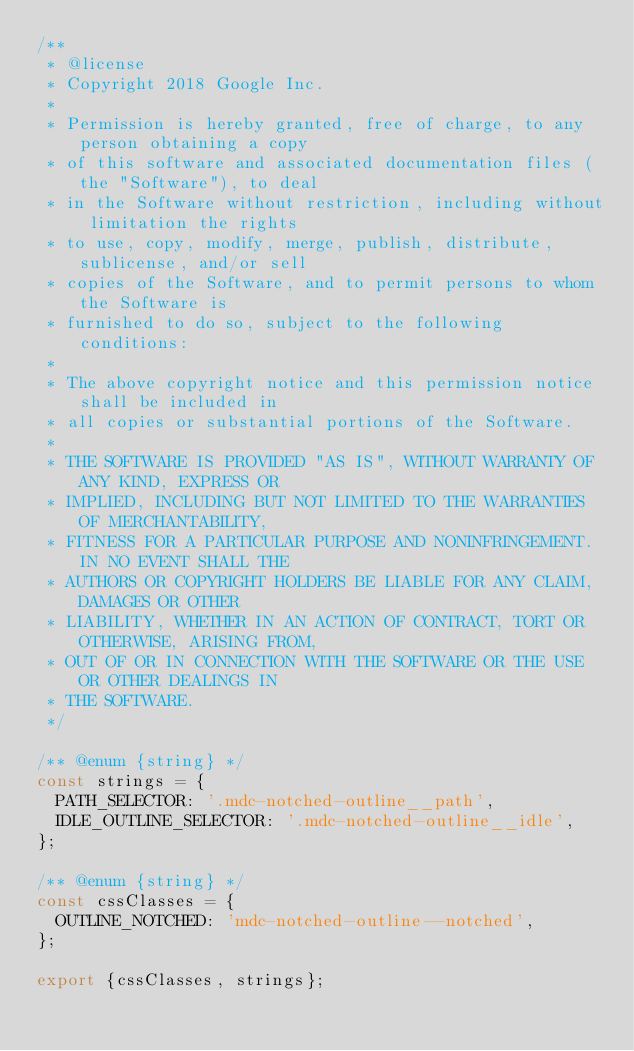<code> <loc_0><loc_0><loc_500><loc_500><_JavaScript_>/**
 * @license
 * Copyright 2018 Google Inc.
 *
 * Permission is hereby granted, free of charge, to any person obtaining a copy
 * of this software and associated documentation files (the "Software"), to deal
 * in the Software without restriction, including without limitation the rights
 * to use, copy, modify, merge, publish, distribute, sublicense, and/or sell
 * copies of the Software, and to permit persons to whom the Software is
 * furnished to do so, subject to the following conditions:
 *
 * The above copyright notice and this permission notice shall be included in
 * all copies or substantial portions of the Software.
 *
 * THE SOFTWARE IS PROVIDED "AS IS", WITHOUT WARRANTY OF ANY KIND, EXPRESS OR
 * IMPLIED, INCLUDING BUT NOT LIMITED TO THE WARRANTIES OF MERCHANTABILITY,
 * FITNESS FOR A PARTICULAR PURPOSE AND NONINFRINGEMENT. IN NO EVENT SHALL THE
 * AUTHORS OR COPYRIGHT HOLDERS BE LIABLE FOR ANY CLAIM, DAMAGES OR OTHER
 * LIABILITY, WHETHER IN AN ACTION OF CONTRACT, TORT OR OTHERWISE, ARISING FROM,
 * OUT OF OR IN CONNECTION WITH THE SOFTWARE OR THE USE OR OTHER DEALINGS IN
 * THE SOFTWARE.
 */

/** @enum {string} */
const strings = {
  PATH_SELECTOR: '.mdc-notched-outline__path',
  IDLE_OUTLINE_SELECTOR: '.mdc-notched-outline__idle',
};

/** @enum {string} */
const cssClasses = {
  OUTLINE_NOTCHED: 'mdc-notched-outline--notched',
};

export {cssClasses, strings};
</code> 